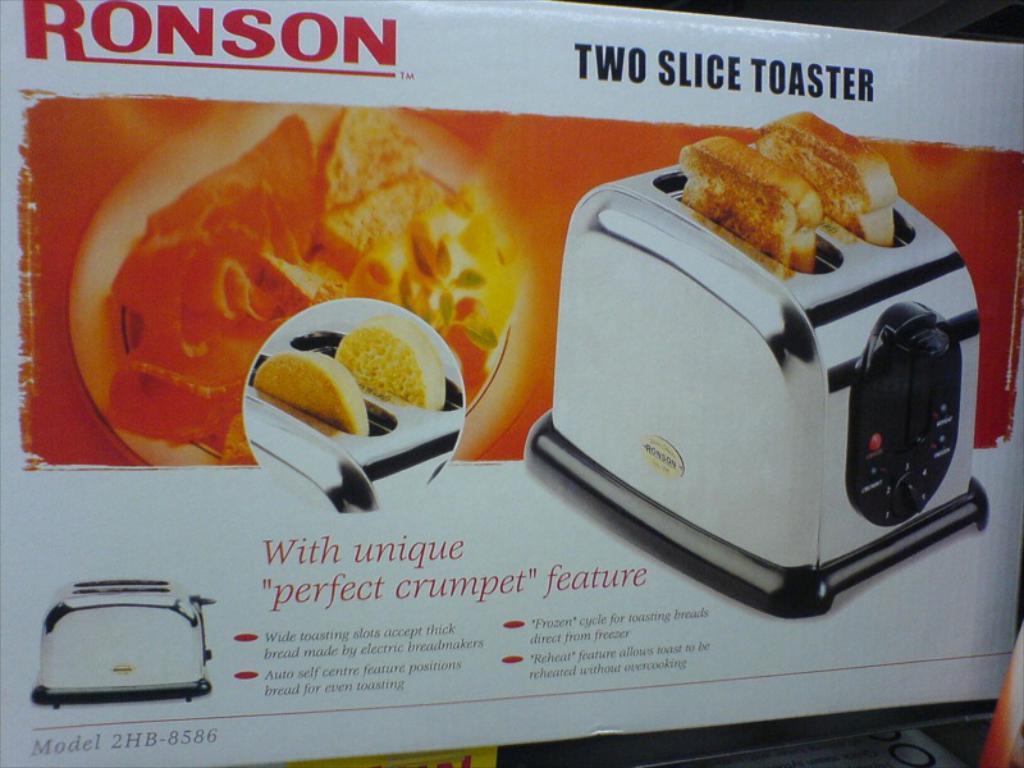What  is the brand of toaster?
Keep it short and to the point. Ronson. Is this an old style ronson toaster?
Offer a terse response. Yes. 